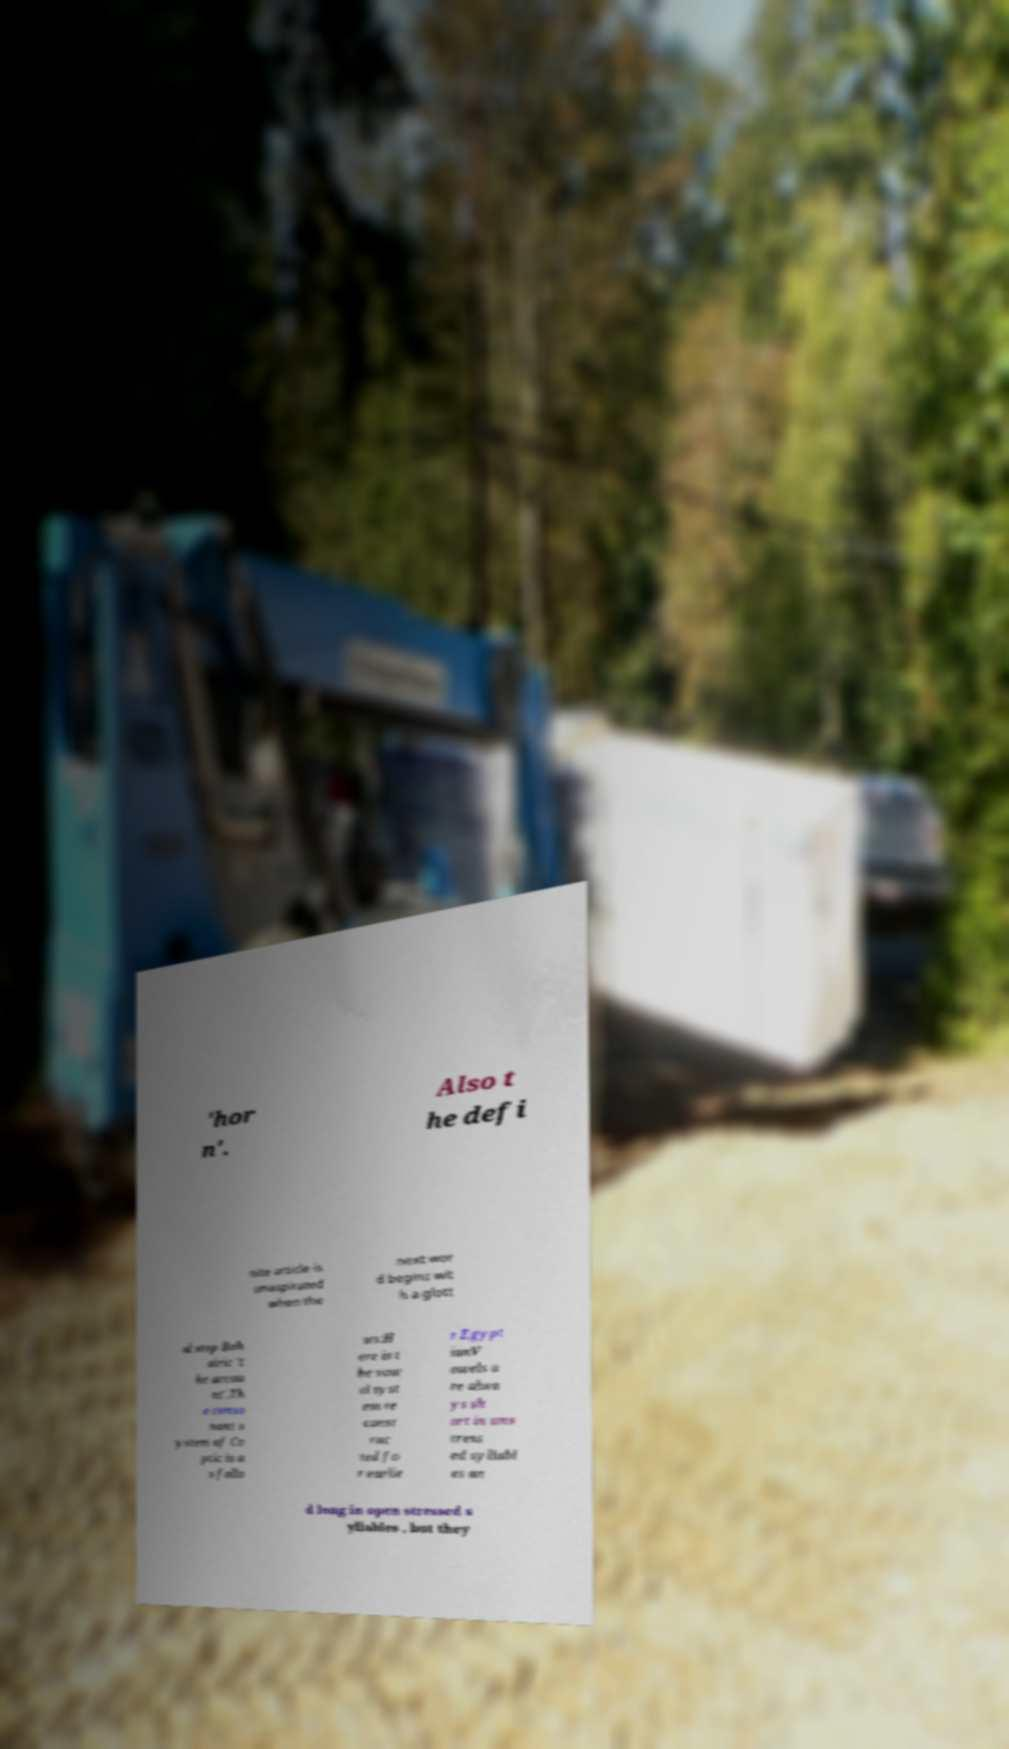Could you assist in decoding the text presented in this image and type it out clearly? 'hor n'. Also t he defi nite article is unaspirated when the next wor d begins wit h a glott al stop Boh airic 't he accou nt'.Th e conso nant s ystem of Co ptic is a s follo ws:H ere is t he vow el syst em re const ruc ted fo r earlie r Egypt ianV owels a re alwa ys sh ort in uns tress ed syllabl es an d long in open stressed s yllables , but they 